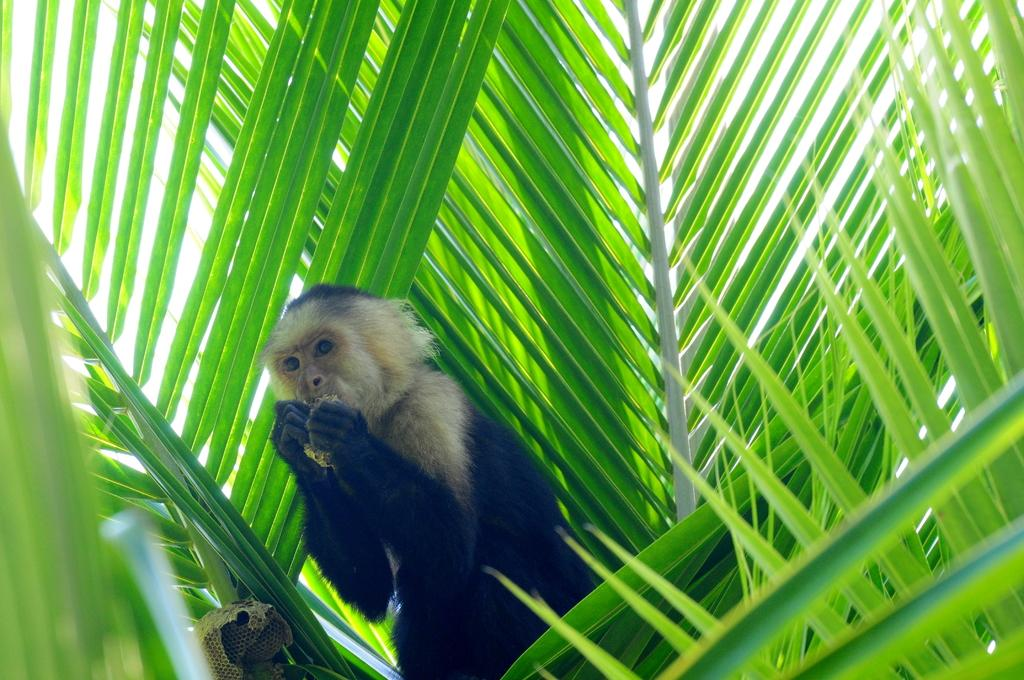What type of animal is in the image? There is a baboon in the image. Where is the baboon located in the image? The baboon is between leaves. What type of grass is the kitty eating in the image? There is no kitty or grass present in the image; it features a baboon between leaves. What is being served for dinner in the image? There is no dinner or indication of food in the image; it only shows a baboon between leaves. 